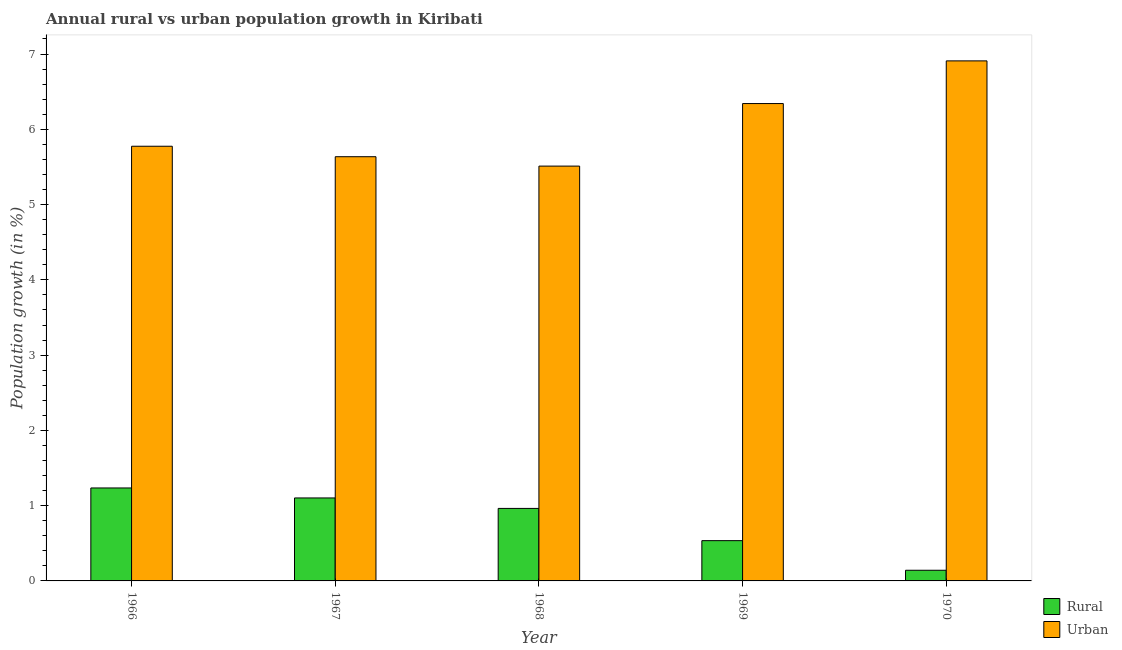How many different coloured bars are there?
Give a very brief answer. 2. How many groups of bars are there?
Ensure brevity in your answer.  5. Are the number of bars per tick equal to the number of legend labels?
Give a very brief answer. Yes. How many bars are there on the 3rd tick from the left?
Keep it short and to the point. 2. What is the label of the 2nd group of bars from the left?
Offer a very short reply. 1967. What is the rural population growth in 1968?
Your answer should be very brief. 0.96. Across all years, what is the maximum urban population growth?
Your answer should be compact. 6.91. Across all years, what is the minimum rural population growth?
Ensure brevity in your answer.  0.14. In which year was the rural population growth maximum?
Provide a short and direct response. 1966. In which year was the rural population growth minimum?
Keep it short and to the point. 1970. What is the total rural population growth in the graph?
Your answer should be very brief. 3.98. What is the difference between the rural population growth in 1968 and that in 1970?
Provide a succinct answer. 0.82. What is the difference between the rural population growth in 1970 and the urban population growth in 1968?
Make the answer very short. -0.82. What is the average rural population growth per year?
Ensure brevity in your answer.  0.8. What is the ratio of the rural population growth in 1967 to that in 1970?
Provide a succinct answer. 7.78. Is the difference between the rural population growth in 1966 and 1970 greater than the difference between the urban population growth in 1966 and 1970?
Give a very brief answer. No. What is the difference between the highest and the second highest rural population growth?
Provide a short and direct response. 0.13. What is the difference between the highest and the lowest urban population growth?
Your answer should be very brief. 1.4. In how many years, is the rural population growth greater than the average rural population growth taken over all years?
Ensure brevity in your answer.  3. Is the sum of the urban population growth in 1966 and 1970 greater than the maximum rural population growth across all years?
Ensure brevity in your answer.  Yes. What does the 2nd bar from the left in 1968 represents?
Ensure brevity in your answer.  Urban . What does the 2nd bar from the right in 1968 represents?
Ensure brevity in your answer.  Rural. How many bars are there?
Your answer should be compact. 10. Are all the bars in the graph horizontal?
Your answer should be very brief. No. Does the graph contain any zero values?
Your answer should be very brief. No. Does the graph contain grids?
Give a very brief answer. No. How are the legend labels stacked?
Ensure brevity in your answer.  Vertical. What is the title of the graph?
Make the answer very short. Annual rural vs urban population growth in Kiribati. Does "Working only" appear as one of the legend labels in the graph?
Provide a short and direct response. No. What is the label or title of the Y-axis?
Keep it short and to the point. Population growth (in %). What is the Population growth (in %) of Rural in 1966?
Your answer should be compact. 1.24. What is the Population growth (in %) in Urban  in 1966?
Your response must be concise. 5.77. What is the Population growth (in %) in Rural in 1967?
Your answer should be compact. 1.1. What is the Population growth (in %) in Urban  in 1967?
Give a very brief answer. 5.64. What is the Population growth (in %) of Rural in 1968?
Provide a succinct answer. 0.96. What is the Population growth (in %) in Urban  in 1968?
Provide a short and direct response. 5.51. What is the Population growth (in %) of Rural in 1969?
Provide a succinct answer. 0.53. What is the Population growth (in %) in Urban  in 1969?
Provide a succinct answer. 6.34. What is the Population growth (in %) of Rural in 1970?
Keep it short and to the point. 0.14. What is the Population growth (in %) of Urban  in 1970?
Provide a succinct answer. 6.91. Across all years, what is the maximum Population growth (in %) of Rural?
Give a very brief answer. 1.24. Across all years, what is the maximum Population growth (in %) in Urban ?
Keep it short and to the point. 6.91. Across all years, what is the minimum Population growth (in %) in Rural?
Your answer should be very brief. 0.14. Across all years, what is the minimum Population growth (in %) in Urban ?
Keep it short and to the point. 5.51. What is the total Population growth (in %) of Rural in the graph?
Your answer should be compact. 3.98. What is the total Population growth (in %) of Urban  in the graph?
Ensure brevity in your answer.  30.17. What is the difference between the Population growth (in %) of Rural in 1966 and that in 1967?
Your response must be concise. 0.13. What is the difference between the Population growth (in %) of Urban  in 1966 and that in 1967?
Ensure brevity in your answer.  0.14. What is the difference between the Population growth (in %) in Rural in 1966 and that in 1968?
Provide a succinct answer. 0.27. What is the difference between the Population growth (in %) of Urban  in 1966 and that in 1968?
Give a very brief answer. 0.26. What is the difference between the Population growth (in %) in Rural in 1966 and that in 1969?
Provide a succinct answer. 0.7. What is the difference between the Population growth (in %) in Urban  in 1966 and that in 1969?
Ensure brevity in your answer.  -0.57. What is the difference between the Population growth (in %) of Rural in 1966 and that in 1970?
Keep it short and to the point. 1.09. What is the difference between the Population growth (in %) of Urban  in 1966 and that in 1970?
Keep it short and to the point. -1.13. What is the difference between the Population growth (in %) in Rural in 1967 and that in 1968?
Offer a terse response. 0.14. What is the difference between the Population growth (in %) in Urban  in 1967 and that in 1968?
Your answer should be compact. 0.12. What is the difference between the Population growth (in %) of Rural in 1967 and that in 1969?
Provide a short and direct response. 0.57. What is the difference between the Population growth (in %) in Urban  in 1967 and that in 1969?
Your answer should be compact. -0.71. What is the difference between the Population growth (in %) of Rural in 1967 and that in 1970?
Ensure brevity in your answer.  0.96. What is the difference between the Population growth (in %) of Urban  in 1967 and that in 1970?
Make the answer very short. -1.27. What is the difference between the Population growth (in %) of Rural in 1968 and that in 1969?
Offer a terse response. 0.43. What is the difference between the Population growth (in %) in Urban  in 1968 and that in 1969?
Give a very brief answer. -0.83. What is the difference between the Population growth (in %) in Rural in 1968 and that in 1970?
Your answer should be very brief. 0.82. What is the difference between the Population growth (in %) in Urban  in 1968 and that in 1970?
Your response must be concise. -1.4. What is the difference between the Population growth (in %) of Rural in 1969 and that in 1970?
Make the answer very short. 0.39. What is the difference between the Population growth (in %) in Urban  in 1969 and that in 1970?
Your answer should be compact. -0.57. What is the difference between the Population growth (in %) of Rural in 1966 and the Population growth (in %) of Urban  in 1967?
Offer a terse response. -4.4. What is the difference between the Population growth (in %) in Rural in 1966 and the Population growth (in %) in Urban  in 1968?
Keep it short and to the point. -4.28. What is the difference between the Population growth (in %) in Rural in 1966 and the Population growth (in %) in Urban  in 1969?
Provide a short and direct response. -5.11. What is the difference between the Population growth (in %) in Rural in 1966 and the Population growth (in %) in Urban  in 1970?
Your answer should be compact. -5.67. What is the difference between the Population growth (in %) in Rural in 1967 and the Population growth (in %) in Urban  in 1968?
Your response must be concise. -4.41. What is the difference between the Population growth (in %) of Rural in 1967 and the Population growth (in %) of Urban  in 1969?
Keep it short and to the point. -5.24. What is the difference between the Population growth (in %) of Rural in 1967 and the Population growth (in %) of Urban  in 1970?
Keep it short and to the point. -5.81. What is the difference between the Population growth (in %) of Rural in 1968 and the Population growth (in %) of Urban  in 1969?
Your answer should be very brief. -5.38. What is the difference between the Population growth (in %) in Rural in 1968 and the Population growth (in %) in Urban  in 1970?
Your answer should be compact. -5.95. What is the difference between the Population growth (in %) of Rural in 1969 and the Population growth (in %) of Urban  in 1970?
Offer a terse response. -6.37. What is the average Population growth (in %) of Rural per year?
Provide a short and direct response. 0.8. What is the average Population growth (in %) of Urban  per year?
Your answer should be compact. 6.03. In the year 1966, what is the difference between the Population growth (in %) of Rural and Population growth (in %) of Urban ?
Offer a terse response. -4.54. In the year 1967, what is the difference between the Population growth (in %) of Rural and Population growth (in %) of Urban ?
Keep it short and to the point. -4.53. In the year 1968, what is the difference between the Population growth (in %) in Rural and Population growth (in %) in Urban ?
Provide a short and direct response. -4.55. In the year 1969, what is the difference between the Population growth (in %) in Rural and Population growth (in %) in Urban ?
Your response must be concise. -5.81. In the year 1970, what is the difference between the Population growth (in %) in Rural and Population growth (in %) in Urban ?
Make the answer very short. -6.77. What is the ratio of the Population growth (in %) in Rural in 1966 to that in 1967?
Give a very brief answer. 1.12. What is the ratio of the Population growth (in %) of Urban  in 1966 to that in 1967?
Give a very brief answer. 1.02. What is the ratio of the Population growth (in %) in Rural in 1966 to that in 1968?
Offer a very short reply. 1.28. What is the ratio of the Population growth (in %) of Urban  in 1966 to that in 1968?
Offer a very short reply. 1.05. What is the ratio of the Population growth (in %) in Rural in 1966 to that in 1969?
Your response must be concise. 2.31. What is the ratio of the Population growth (in %) in Urban  in 1966 to that in 1969?
Your answer should be very brief. 0.91. What is the ratio of the Population growth (in %) in Rural in 1966 to that in 1970?
Provide a short and direct response. 8.72. What is the ratio of the Population growth (in %) in Urban  in 1966 to that in 1970?
Offer a terse response. 0.84. What is the ratio of the Population growth (in %) of Rural in 1967 to that in 1968?
Offer a very short reply. 1.14. What is the ratio of the Population growth (in %) of Urban  in 1967 to that in 1968?
Make the answer very short. 1.02. What is the ratio of the Population growth (in %) in Rural in 1967 to that in 1969?
Provide a short and direct response. 2.06. What is the ratio of the Population growth (in %) of Urban  in 1967 to that in 1969?
Your response must be concise. 0.89. What is the ratio of the Population growth (in %) of Rural in 1967 to that in 1970?
Make the answer very short. 7.78. What is the ratio of the Population growth (in %) in Urban  in 1967 to that in 1970?
Ensure brevity in your answer.  0.82. What is the ratio of the Population growth (in %) in Rural in 1968 to that in 1969?
Offer a terse response. 1.8. What is the ratio of the Population growth (in %) in Urban  in 1968 to that in 1969?
Give a very brief answer. 0.87. What is the ratio of the Population growth (in %) of Rural in 1968 to that in 1970?
Offer a terse response. 6.8. What is the ratio of the Population growth (in %) in Urban  in 1968 to that in 1970?
Offer a very short reply. 0.8. What is the ratio of the Population growth (in %) in Rural in 1969 to that in 1970?
Your response must be concise. 3.78. What is the ratio of the Population growth (in %) of Urban  in 1969 to that in 1970?
Keep it short and to the point. 0.92. What is the difference between the highest and the second highest Population growth (in %) in Rural?
Offer a very short reply. 0.13. What is the difference between the highest and the second highest Population growth (in %) in Urban ?
Provide a short and direct response. 0.57. What is the difference between the highest and the lowest Population growth (in %) in Rural?
Offer a very short reply. 1.09. What is the difference between the highest and the lowest Population growth (in %) in Urban ?
Your answer should be compact. 1.4. 